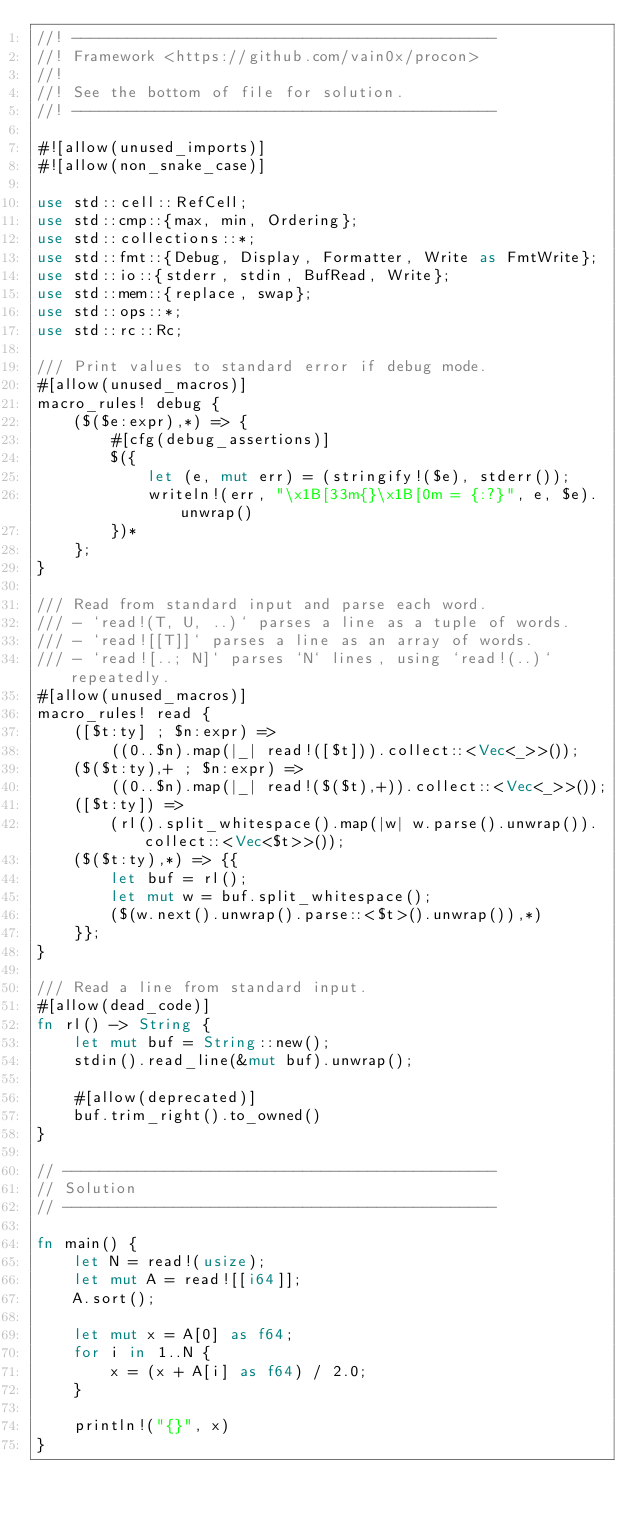<code> <loc_0><loc_0><loc_500><loc_500><_Rust_>//! ----------------------------------------------
//! Framework <https://github.com/vain0x/procon>
//!
//! See the bottom of file for solution.
//! ----------------------------------------------

#![allow(unused_imports)]
#![allow(non_snake_case)]

use std::cell::RefCell;
use std::cmp::{max, min, Ordering};
use std::collections::*;
use std::fmt::{Debug, Display, Formatter, Write as FmtWrite};
use std::io::{stderr, stdin, BufRead, Write};
use std::mem::{replace, swap};
use std::ops::*;
use std::rc::Rc;

/// Print values to standard error if debug mode.
#[allow(unused_macros)]
macro_rules! debug {
    ($($e:expr),*) => {
        #[cfg(debug_assertions)]
        $({
            let (e, mut err) = (stringify!($e), stderr());
            writeln!(err, "\x1B[33m{}\x1B[0m = {:?}", e, $e).unwrap()
        })*
    };
}

/// Read from standard input and parse each word.
/// - `read!(T, U, ..)` parses a line as a tuple of words.
/// - `read![[T]]` parses a line as an array of words.
/// - `read![..; N]` parses `N` lines, using `read!(..)` repeatedly.
#[allow(unused_macros)]
macro_rules! read {
    ([$t:ty] ; $n:expr) =>
        ((0..$n).map(|_| read!([$t])).collect::<Vec<_>>());
    ($($t:ty),+ ; $n:expr) =>
        ((0..$n).map(|_| read!($($t),+)).collect::<Vec<_>>());
    ([$t:ty]) =>
        (rl().split_whitespace().map(|w| w.parse().unwrap()).collect::<Vec<$t>>());
    ($($t:ty),*) => {{
        let buf = rl();
        let mut w = buf.split_whitespace();
        ($(w.next().unwrap().parse::<$t>().unwrap()),*)
    }};
}

/// Read a line from standard input.
#[allow(dead_code)]
fn rl() -> String {
    let mut buf = String::new();
    stdin().read_line(&mut buf).unwrap();

    #[allow(deprecated)]
    buf.trim_right().to_owned()
}

// -----------------------------------------------
// Solution
// -----------------------------------------------

fn main() {
    let N = read!(usize);
    let mut A = read![[i64]];
    A.sort();

    let mut x = A[0] as f64;
    for i in 1..N {
        x = (x + A[i] as f64) / 2.0;
    }

    println!("{}", x)
}
</code> 